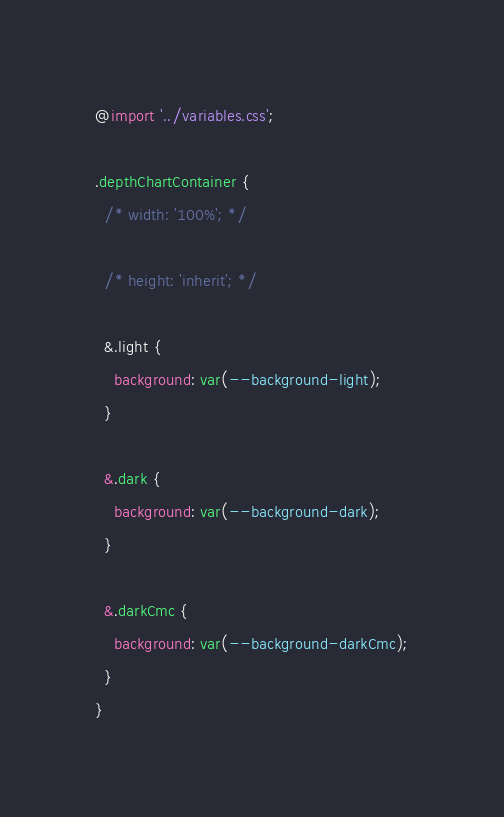Convert code to text. <code><loc_0><loc_0><loc_500><loc_500><_CSS_>@import '../variables.css';

.depthChartContainer {
  /* width: '100%'; */

  /* height: 'inherit'; */

  &.light {
    background: var(--background-light);
  }

  &.dark {
    background: var(--background-dark);
  }

  &.darkCmc {
    background: var(--background-darkCmc);
  }
}
</code> 